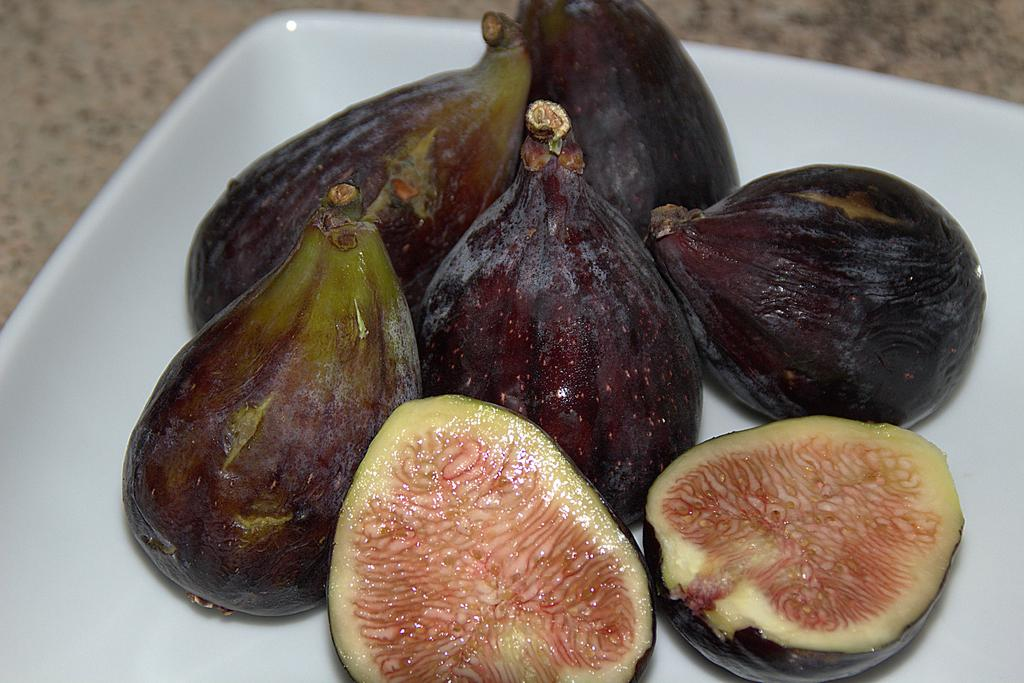What type of fruits are visible in the image? There are common fig fruits in the image. How are the fig fruits arranged or placed in the image? The fig fruits are kept on a plate in the image. What type of plastic material is used to make the discovery in the image? There is no mention of a discovery or plastic material in the image; it features common fig fruits on a plate. 